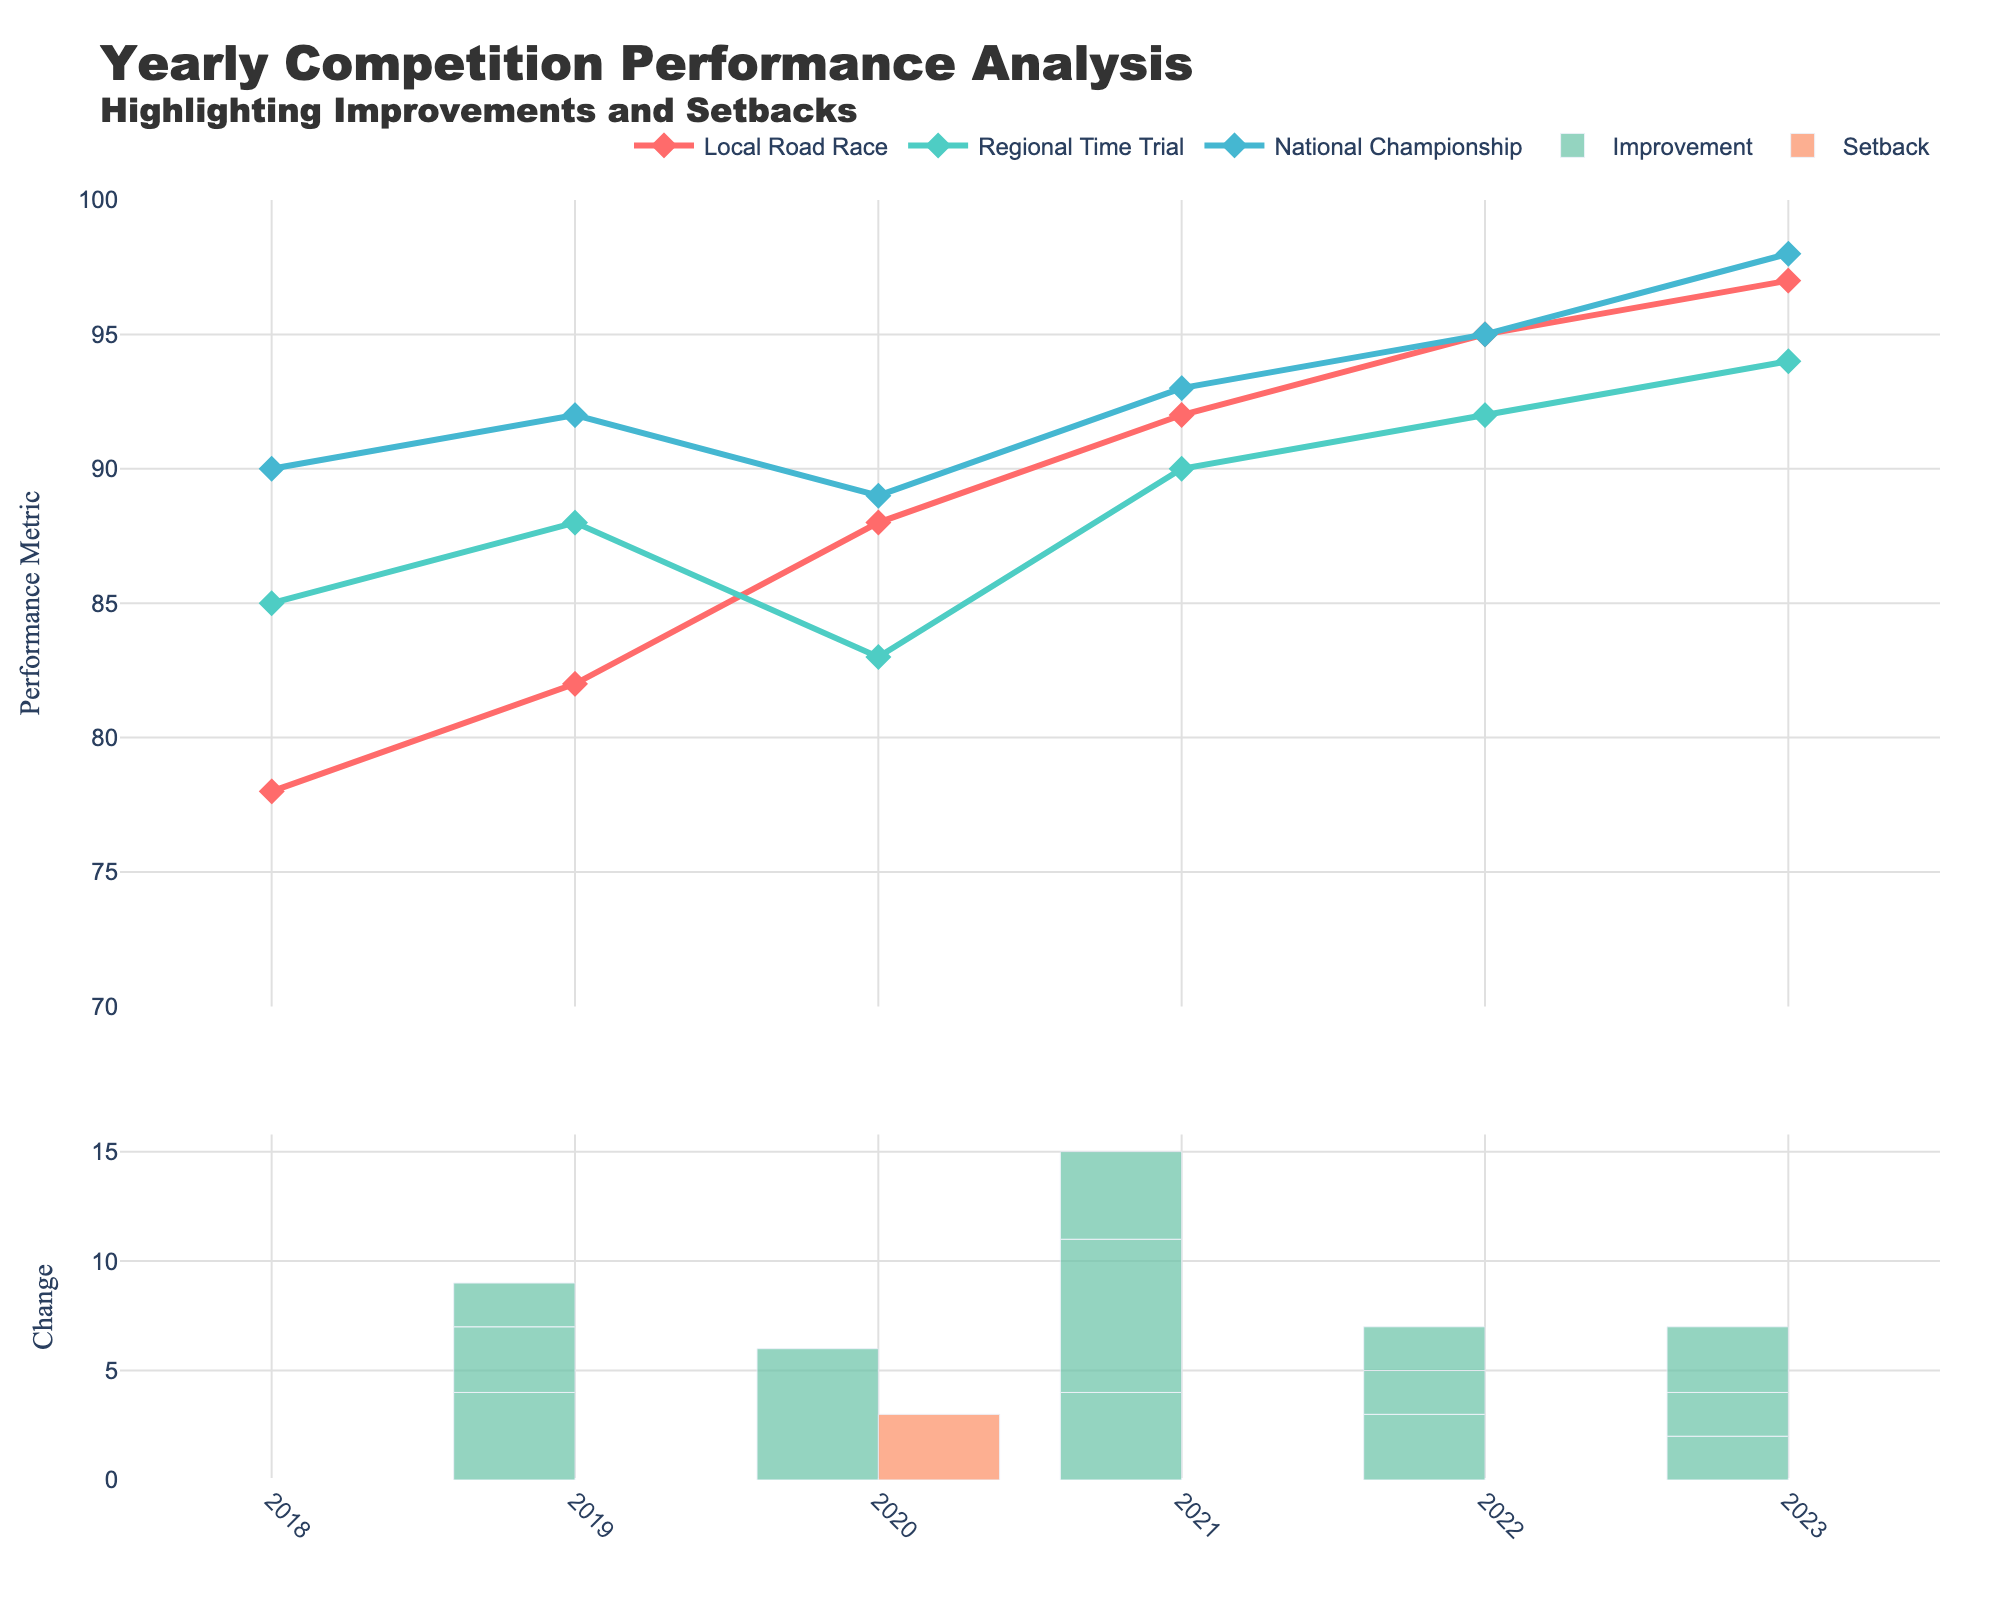What's the performance metric for the Local Road Race in 2023? Refer to the line for Local Road Race and find the value for the year 2023, which is the top-most point on this line.
Answer: 97 How many total setbacks were recorded in 2020? Identify the bar for setbacks in 2020 from the lower plot and read its height. There's only one setback value for the National Championship.
Answer: 3 Which competition had the highest performance metric in 2022? Compare the markers in 2022 for Local Road Race, Regional Time Trial, and National Championship. The highest point is for National Championship.
Answer: National Championship What was the overall trend in the performance metric from 2018 to 2023 for the Regional Time Trial? Evaluate the markers and line for Regional Time Trial across the years: performance increased steadily from 2018 to 2023.
Answer: Increasing Which year had the highest improvement recorded? In the lower plot, identify the tallest green bar, which corresponds to Improvement. This occurred in 2021.
Answer: 2021 What is the average performance metric for the National Championship across the years? Sum all the performance metrics for National Championship (90 + 92 + 89 + 93 + 95 + 98) and divide by the number of years (6). Calculation: (90 + 92 + 89 + 93 + 95 + 98) / 6 = 91.1667
Answer: 91.17 How many improvements were recorded in 2019? Refer to the lower plot and read the green bar height for 2019, which is 4.
Answer: 4 How does the performance in 2020 for the Local Road Race compare to the National Championship? Compare their respective markers: Local Road Race has a performance metric of 88, while National Championship has 89. Thus, the National Championship is slightly higher.
Answer: National Championship is slightly higher What change happened for the Regional Time Trial between 2019 and 2020? Look at the respective points in 2019 (88) and in 2020 (83) and calculate the difference (88 - 83 = 5). This gives a decrease.
Answer: Decrease of 5 Which competition shows the most consistent performance increase from 2018 to 2023? Compare the trends for all three competitions. Local Road Race shows steady and consistent improvement with no decreases (78 to 82 to 88 to 92 to 95 to 97).
Answer: Local Road Race 